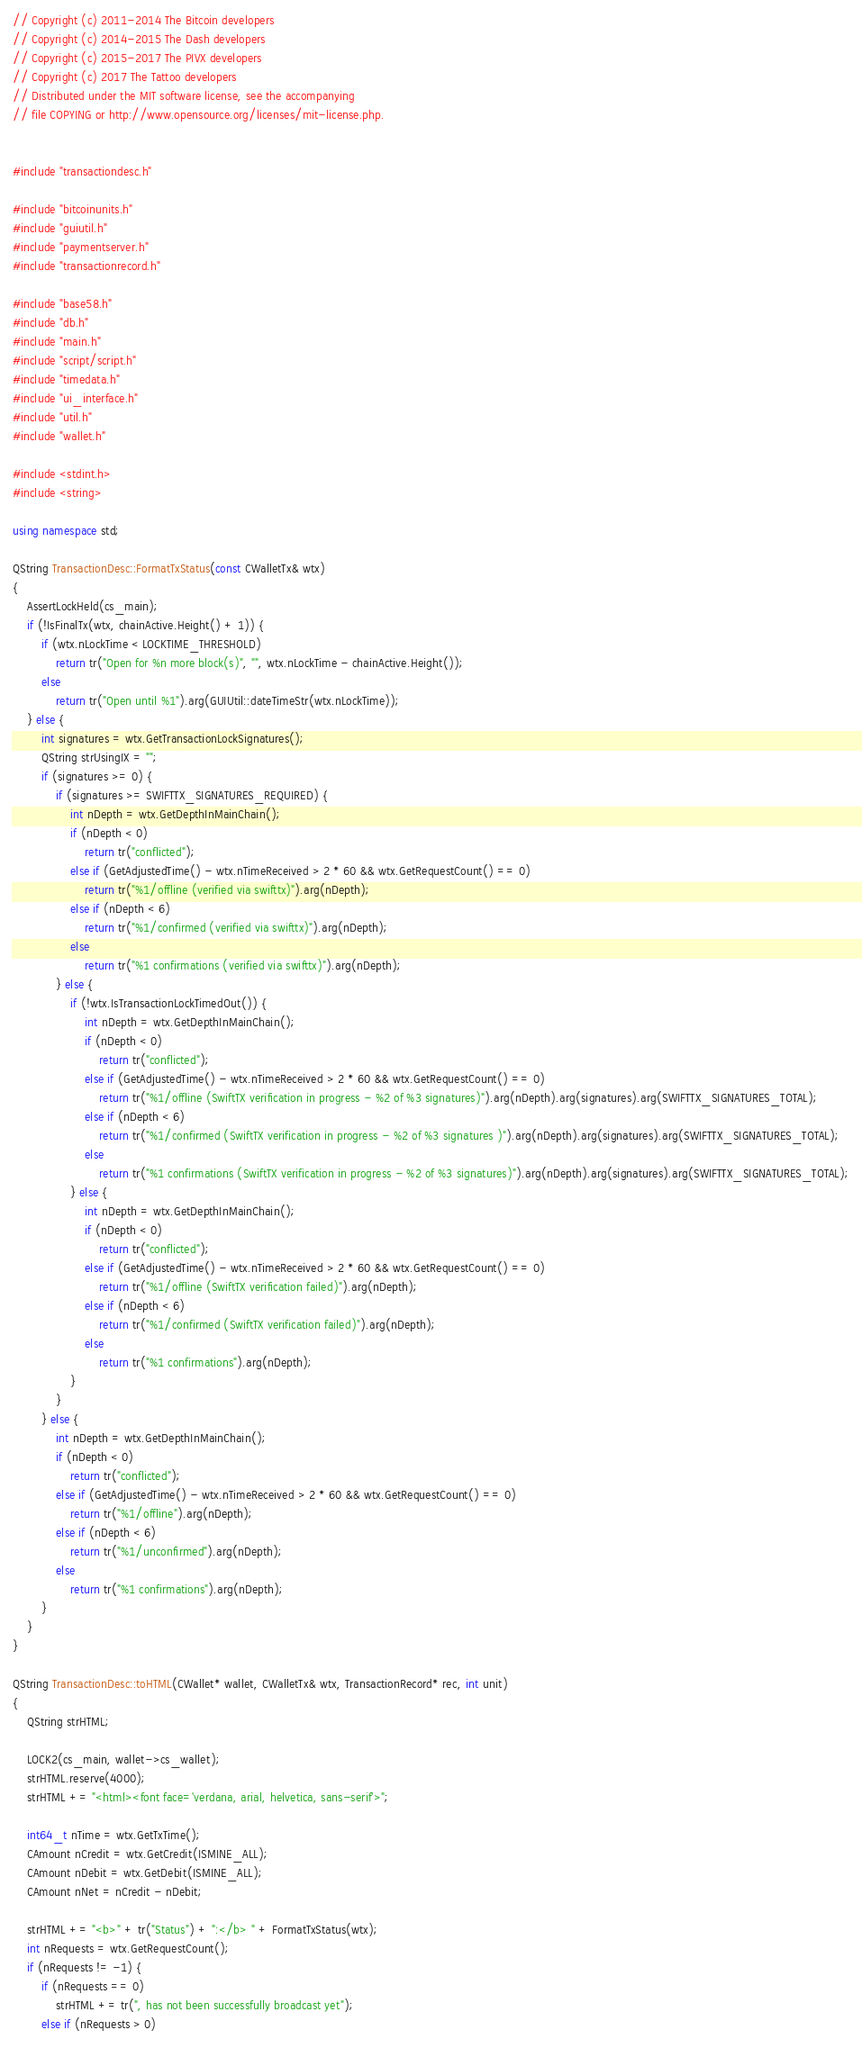<code> <loc_0><loc_0><loc_500><loc_500><_C++_>// Copyright (c) 2011-2014 The Bitcoin developers
// Copyright (c) 2014-2015 The Dash developers
// Copyright (c) 2015-2017 The PIVX developers
// Copyright (c) 2017 The Tattoo developers
// Distributed under the MIT software license, see the accompanying
// file COPYING or http://www.opensource.org/licenses/mit-license.php.


#include "transactiondesc.h"

#include "bitcoinunits.h"
#include "guiutil.h"
#include "paymentserver.h"
#include "transactionrecord.h"

#include "base58.h"
#include "db.h"
#include "main.h"
#include "script/script.h"
#include "timedata.h"
#include "ui_interface.h"
#include "util.h"
#include "wallet.h"

#include <stdint.h>
#include <string>

using namespace std;

QString TransactionDesc::FormatTxStatus(const CWalletTx& wtx)
{
    AssertLockHeld(cs_main);
    if (!IsFinalTx(wtx, chainActive.Height() + 1)) {
        if (wtx.nLockTime < LOCKTIME_THRESHOLD)
            return tr("Open for %n more block(s)", "", wtx.nLockTime - chainActive.Height());
        else
            return tr("Open until %1").arg(GUIUtil::dateTimeStr(wtx.nLockTime));
    } else {
        int signatures = wtx.GetTransactionLockSignatures();
        QString strUsingIX = "";
        if (signatures >= 0) {
            if (signatures >= SWIFTTX_SIGNATURES_REQUIRED) {
                int nDepth = wtx.GetDepthInMainChain();
                if (nDepth < 0)
                    return tr("conflicted");
                else if (GetAdjustedTime() - wtx.nTimeReceived > 2 * 60 && wtx.GetRequestCount() == 0)
                    return tr("%1/offline (verified via swifttx)").arg(nDepth);
                else if (nDepth < 6)
                    return tr("%1/confirmed (verified via swifttx)").arg(nDepth);
                else
                    return tr("%1 confirmations (verified via swifttx)").arg(nDepth);
            } else {
                if (!wtx.IsTransactionLockTimedOut()) {
                    int nDepth = wtx.GetDepthInMainChain();
                    if (nDepth < 0)
                        return tr("conflicted");
                    else if (GetAdjustedTime() - wtx.nTimeReceived > 2 * 60 && wtx.GetRequestCount() == 0)
                        return tr("%1/offline (SwiftTX verification in progress - %2 of %3 signatures)").arg(nDepth).arg(signatures).arg(SWIFTTX_SIGNATURES_TOTAL);
                    else if (nDepth < 6)
                        return tr("%1/confirmed (SwiftTX verification in progress - %2 of %3 signatures )").arg(nDepth).arg(signatures).arg(SWIFTTX_SIGNATURES_TOTAL);
                    else
                        return tr("%1 confirmations (SwiftTX verification in progress - %2 of %3 signatures)").arg(nDepth).arg(signatures).arg(SWIFTTX_SIGNATURES_TOTAL);
                } else {
                    int nDepth = wtx.GetDepthInMainChain();
                    if (nDepth < 0)
                        return tr("conflicted");
                    else if (GetAdjustedTime() - wtx.nTimeReceived > 2 * 60 && wtx.GetRequestCount() == 0)
                        return tr("%1/offline (SwiftTX verification failed)").arg(nDepth);
                    else if (nDepth < 6)
                        return tr("%1/confirmed (SwiftTX verification failed)").arg(nDepth);
                    else
                        return tr("%1 confirmations").arg(nDepth);
                }
            }
        } else {
            int nDepth = wtx.GetDepthInMainChain();
            if (nDepth < 0)
                return tr("conflicted");
            else if (GetAdjustedTime() - wtx.nTimeReceived > 2 * 60 && wtx.GetRequestCount() == 0)
                return tr("%1/offline").arg(nDepth);
            else if (nDepth < 6)
                return tr("%1/unconfirmed").arg(nDepth);
            else
                return tr("%1 confirmations").arg(nDepth);
        }
    }
}

QString TransactionDesc::toHTML(CWallet* wallet, CWalletTx& wtx, TransactionRecord* rec, int unit)
{
    QString strHTML;

    LOCK2(cs_main, wallet->cs_wallet);
    strHTML.reserve(4000);
    strHTML += "<html><font face='verdana, arial, helvetica, sans-serif'>";

    int64_t nTime = wtx.GetTxTime();
    CAmount nCredit = wtx.GetCredit(ISMINE_ALL);
    CAmount nDebit = wtx.GetDebit(ISMINE_ALL);
    CAmount nNet = nCredit - nDebit;

    strHTML += "<b>" + tr("Status") + ":</b> " + FormatTxStatus(wtx);
    int nRequests = wtx.GetRequestCount();
    if (nRequests != -1) {
        if (nRequests == 0)
            strHTML += tr(", has not been successfully broadcast yet");
        else if (nRequests > 0)</code> 